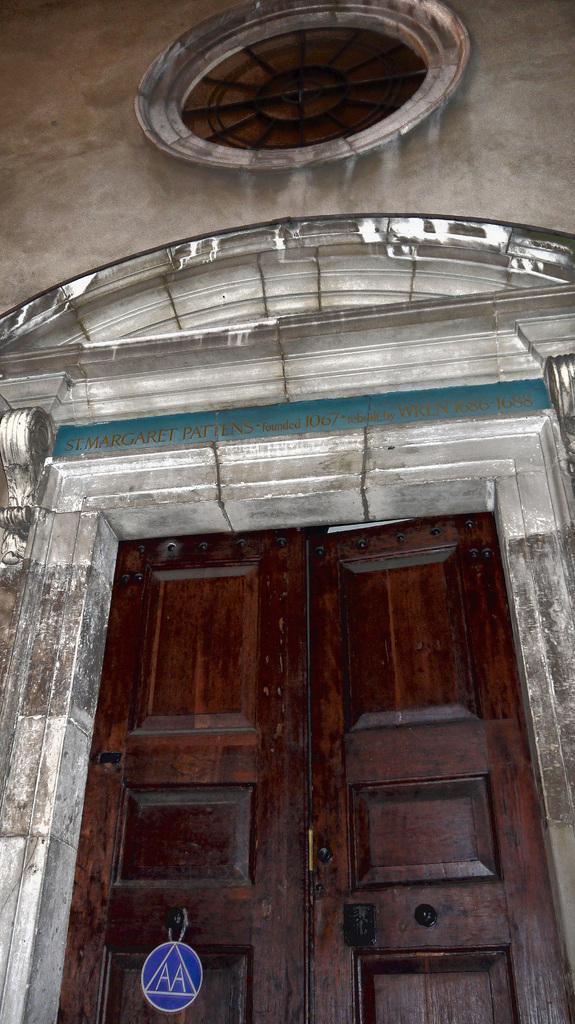Can you describe this image briefly? In this image in the center there is a door and on the top of the door there is a window and there is a wall, and there is some text written on the wall. 